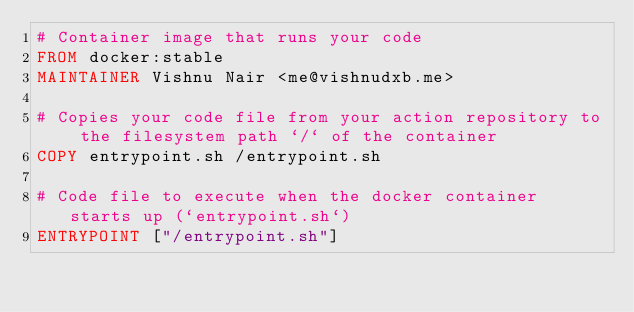<code> <loc_0><loc_0><loc_500><loc_500><_Dockerfile_># Container image that runs your code
FROM docker:stable
MAINTAINER Vishnu Nair <me@vishnudxb.me>

# Copies your code file from your action repository to the filesystem path `/` of the container
COPY entrypoint.sh /entrypoint.sh

# Code file to execute when the docker container starts up (`entrypoint.sh`)
ENTRYPOINT ["/entrypoint.sh"]
</code> 